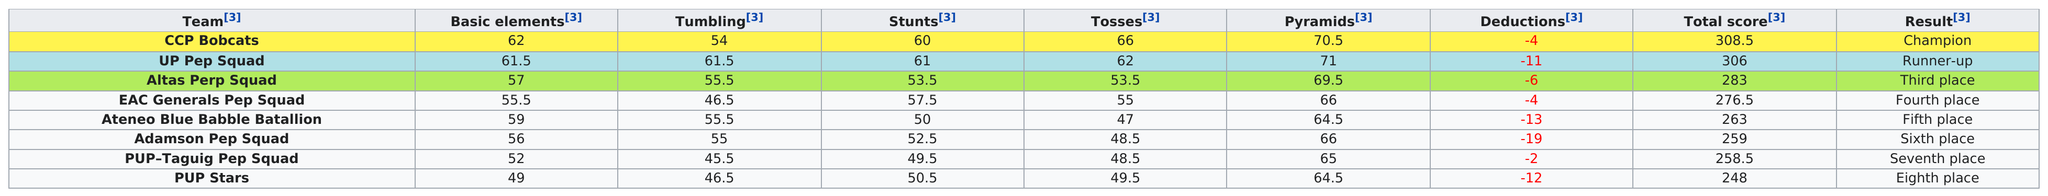Highlight a few significant elements in this photo. The PUP Stars team had the lowest total score among all the teams. The UP Pep Squad had the most pyramids. Out of the teams that received a lower score in the pyramids category, the Adamson Pep Squad received the third lowest score. I declare that, besides CCP Bobcats, who has more than 60 basic elements, UP Pep Squad exists. The number of teams that had more pyramids than the Atlas perp squad was two. 